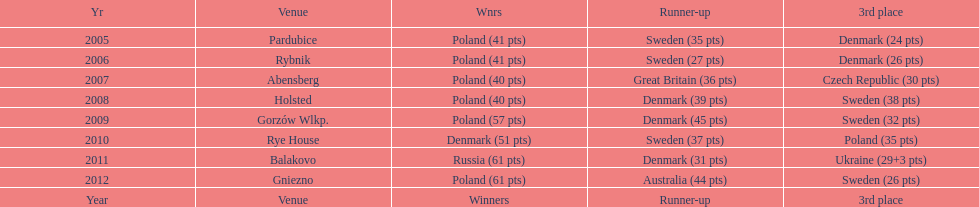Which team has the most third place wins in the speedway junior world championship between 2005 and 2012? Sweden. 